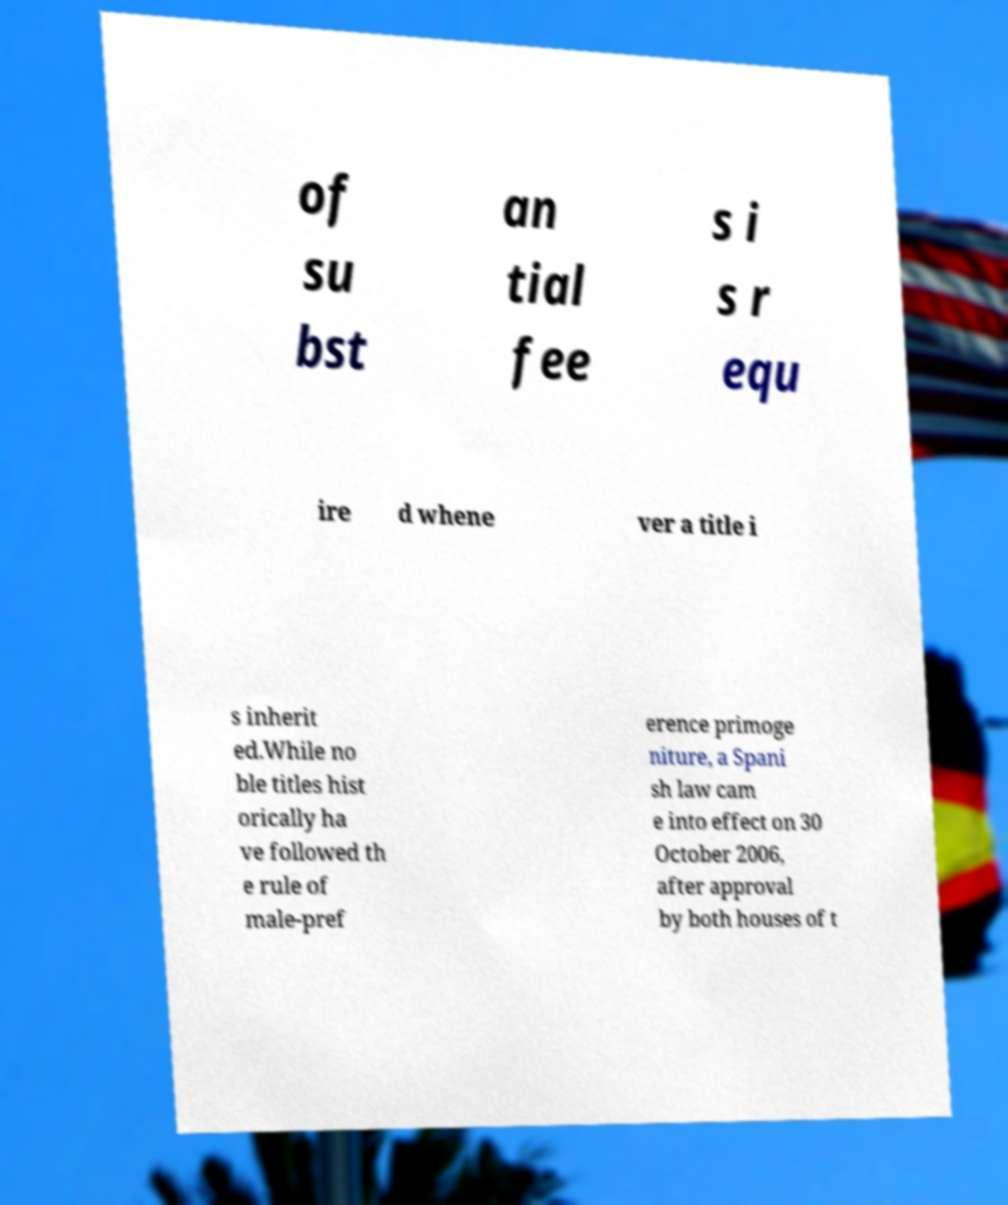Could you extract and type out the text from this image? of su bst an tial fee s i s r equ ire d whene ver a title i s inherit ed.While no ble titles hist orically ha ve followed th e rule of male-pref erence primoge niture, a Spani sh law cam e into effect on 30 October 2006, after approval by both houses of t 